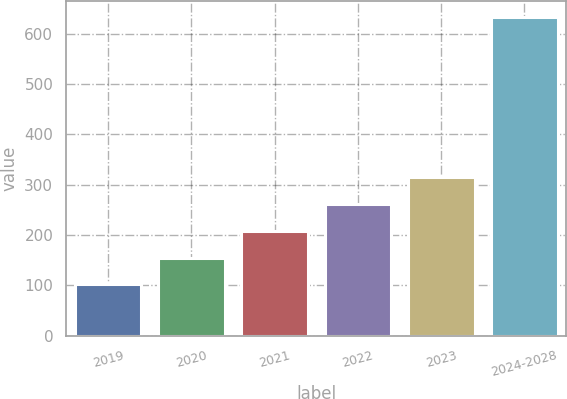Convert chart. <chart><loc_0><loc_0><loc_500><loc_500><bar_chart><fcel>2019<fcel>2020<fcel>2021<fcel>2022<fcel>2023<fcel>2024-2028<nl><fcel>102<fcel>155.2<fcel>208.4<fcel>261.6<fcel>314.8<fcel>634<nl></chart> 